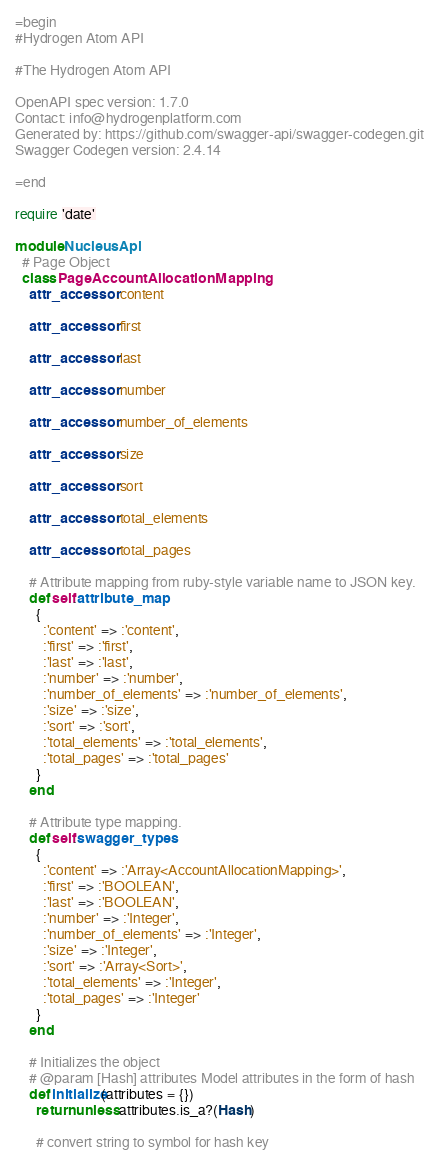<code> <loc_0><loc_0><loc_500><loc_500><_Ruby_>=begin
#Hydrogen Atom API

#The Hydrogen Atom API

OpenAPI spec version: 1.7.0
Contact: info@hydrogenplatform.com
Generated by: https://github.com/swagger-api/swagger-codegen.git
Swagger Codegen version: 2.4.14

=end

require 'date'

module NucleusApi
  # Page Object
  class PageAccountAllocationMapping
    attr_accessor :content

    attr_accessor :first

    attr_accessor :last

    attr_accessor :number

    attr_accessor :number_of_elements

    attr_accessor :size

    attr_accessor :sort

    attr_accessor :total_elements

    attr_accessor :total_pages

    # Attribute mapping from ruby-style variable name to JSON key.
    def self.attribute_map
      {
        :'content' => :'content',
        :'first' => :'first',
        :'last' => :'last',
        :'number' => :'number',
        :'number_of_elements' => :'number_of_elements',
        :'size' => :'size',
        :'sort' => :'sort',
        :'total_elements' => :'total_elements',
        :'total_pages' => :'total_pages'
      }
    end

    # Attribute type mapping.
    def self.swagger_types
      {
        :'content' => :'Array<AccountAllocationMapping>',
        :'first' => :'BOOLEAN',
        :'last' => :'BOOLEAN',
        :'number' => :'Integer',
        :'number_of_elements' => :'Integer',
        :'size' => :'Integer',
        :'sort' => :'Array<Sort>',
        :'total_elements' => :'Integer',
        :'total_pages' => :'Integer'
      }
    end

    # Initializes the object
    # @param [Hash] attributes Model attributes in the form of hash
    def initialize(attributes = {})
      return unless attributes.is_a?(Hash)

      # convert string to symbol for hash key</code> 